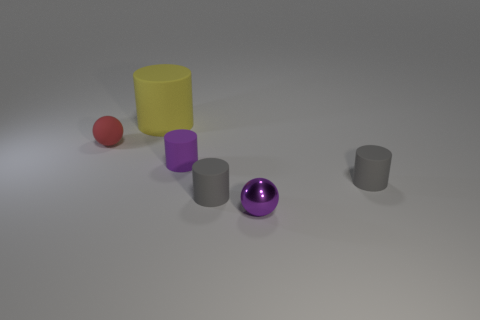Subtract all gray blocks. How many gray cylinders are left? 2 Subtract all yellow cylinders. How many cylinders are left? 3 Subtract 2 cylinders. How many cylinders are left? 2 Subtract all purple cylinders. How many cylinders are left? 3 Add 3 small brown shiny objects. How many objects exist? 9 Subtract all spheres. How many objects are left? 4 Subtract all green cylinders. Subtract all red cubes. How many cylinders are left? 4 Add 4 small purple things. How many small purple things are left? 6 Add 4 blue rubber things. How many blue rubber things exist? 4 Subtract 0 brown cylinders. How many objects are left? 6 